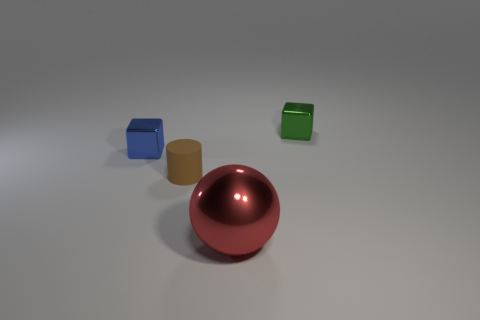Can you describe the colors of the objects? Certainly, there's a red shiny sphere, a metallic gold cylinder, a blue cube, and a green cube. 